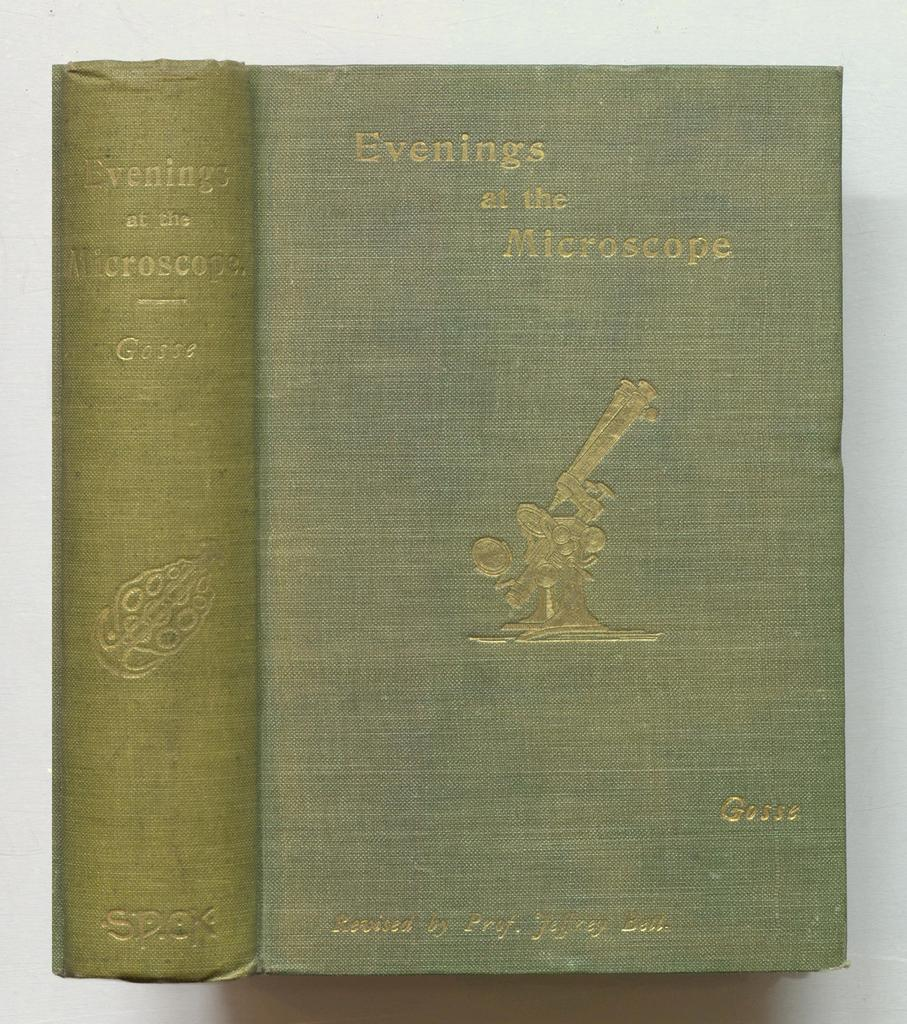Provide a one-sentence caption for the provided image. An old green book called "Evenings at the Microscope". 